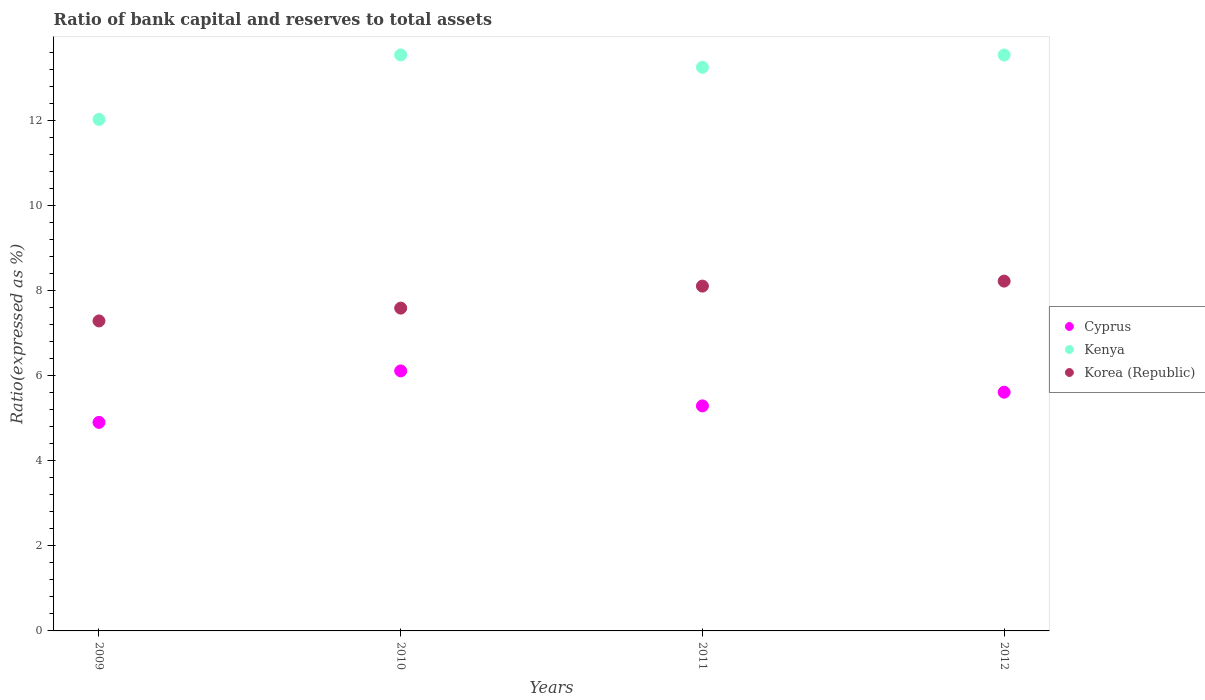How many different coloured dotlines are there?
Keep it short and to the point. 3. Is the number of dotlines equal to the number of legend labels?
Your response must be concise. Yes. What is the ratio of bank capital and reserves to total assets in Cyprus in 2011?
Provide a short and direct response. 5.3. Across all years, what is the maximum ratio of bank capital and reserves to total assets in Kenya?
Provide a short and direct response. 13.55. Across all years, what is the minimum ratio of bank capital and reserves to total assets in Kenya?
Provide a short and direct response. 12.04. In which year was the ratio of bank capital and reserves to total assets in Kenya maximum?
Offer a terse response. 2010. In which year was the ratio of bank capital and reserves to total assets in Kenya minimum?
Provide a short and direct response. 2009. What is the total ratio of bank capital and reserves to total assets in Korea (Republic) in the graph?
Your answer should be compact. 31.23. What is the difference between the ratio of bank capital and reserves to total assets in Korea (Republic) in 2010 and that in 2012?
Your answer should be compact. -0.64. What is the difference between the ratio of bank capital and reserves to total assets in Kenya in 2012 and the ratio of bank capital and reserves to total assets in Korea (Republic) in 2009?
Make the answer very short. 6.26. What is the average ratio of bank capital and reserves to total assets in Korea (Republic) per year?
Your answer should be compact. 7.81. In the year 2012, what is the difference between the ratio of bank capital and reserves to total assets in Korea (Republic) and ratio of bank capital and reserves to total assets in Kenya?
Provide a succinct answer. -5.32. In how many years, is the ratio of bank capital and reserves to total assets in Korea (Republic) greater than 5.2 %?
Keep it short and to the point. 4. What is the ratio of the ratio of bank capital and reserves to total assets in Korea (Republic) in 2009 to that in 2010?
Offer a very short reply. 0.96. Is the difference between the ratio of bank capital and reserves to total assets in Korea (Republic) in 2011 and 2012 greater than the difference between the ratio of bank capital and reserves to total assets in Kenya in 2011 and 2012?
Provide a succinct answer. Yes. What is the difference between the highest and the second highest ratio of bank capital and reserves to total assets in Kenya?
Make the answer very short. 0. What is the difference between the highest and the lowest ratio of bank capital and reserves to total assets in Cyprus?
Provide a short and direct response. 1.21. In how many years, is the ratio of bank capital and reserves to total assets in Kenya greater than the average ratio of bank capital and reserves to total assets in Kenya taken over all years?
Your response must be concise. 3. Is it the case that in every year, the sum of the ratio of bank capital and reserves to total assets in Cyprus and ratio of bank capital and reserves to total assets in Korea (Republic)  is greater than the ratio of bank capital and reserves to total assets in Kenya?
Offer a terse response. Yes. Is the ratio of bank capital and reserves to total assets in Cyprus strictly less than the ratio of bank capital and reserves to total assets in Kenya over the years?
Offer a terse response. Yes. How many dotlines are there?
Provide a succinct answer. 3. How many years are there in the graph?
Provide a short and direct response. 4. Are the values on the major ticks of Y-axis written in scientific E-notation?
Keep it short and to the point. No. Does the graph contain grids?
Give a very brief answer. No. Where does the legend appear in the graph?
Provide a succinct answer. Center right. How are the legend labels stacked?
Offer a very short reply. Vertical. What is the title of the graph?
Provide a short and direct response. Ratio of bank capital and reserves to total assets. Does "Liberia" appear as one of the legend labels in the graph?
Your answer should be very brief. No. What is the label or title of the X-axis?
Provide a succinct answer. Years. What is the label or title of the Y-axis?
Offer a very short reply. Ratio(expressed as %). What is the Ratio(expressed as %) of Cyprus in 2009?
Make the answer very short. 4.91. What is the Ratio(expressed as %) in Kenya in 2009?
Provide a succinct answer. 12.04. What is the Ratio(expressed as %) in Korea (Republic) in 2009?
Make the answer very short. 7.29. What is the Ratio(expressed as %) in Cyprus in 2010?
Keep it short and to the point. 6.12. What is the Ratio(expressed as %) of Kenya in 2010?
Offer a terse response. 13.55. What is the Ratio(expressed as %) in Korea (Republic) in 2010?
Your response must be concise. 7.6. What is the Ratio(expressed as %) of Cyprus in 2011?
Offer a very short reply. 5.3. What is the Ratio(expressed as %) in Kenya in 2011?
Give a very brief answer. 13.26. What is the Ratio(expressed as %) of Korea (Republic) in 2011?
Ensure brevity in your answer.  8.11. What is the Ratio(expressed as %) in Cyprus in 2012?
Offer a very short reply. 5.62. What is the Ratio(expressed as %) of Kenya in 2012?
Provide a short and direct response. 13.55. What is the Ratio(expressed as %) in Korea (Republic) in 2012?
Your answer should be very brief. 8.23. Across all years, what is the maximum Ratio(expressed as %) of Cyprus?
Ensure brevity in your answer.  6.12. Across all years, what is the maximum Ratio(expressed as %) in Kenya?
Provide a short and direct response. 13.55. Across all years, what is the maximum Ratio(expressed as %) in Korea (Republic)?
Make the answer very short. 8.23. Across all years, what is the minimum Ratio(expressed as %) of Cyprus?
Keep it short and to the point. 4.91. Across all years, what is the minimum Ratio(expressed as %) of Kenya?
Make the answer very short. 12.04. Across all years, what is the minimum Ratio(expressed as %) in Korea (Republic)?
Your answer should be very brief. 7.29. What is the total Ratio(expressed as %) in Cyprus in the graph?
Ensure brevity in your answer.  21.94. What is the total Ratio(expressed as %) of Kenya in the graph?
Ensure brevity in your answer.  52.4. What is the total Ratio(expressed as %) in Korea (Republic) in the graph?
Make the answer very short. 31.23. What is the difference between the Ratio(expressed as %) of Cyprus in 2009 and that in 2010?
Offer a very short reply. -1.21. What is the difference between the Ratio(expressed as %) of Kenya in 2009 and that in 2010?
Provide a short and direct response. -1.52. What is the difference between the Ratio(expressed as %) in Korea (Republic) in 2009 and that in 2010?
Provide a short and direct response. -0.3. What is the difference between the Ratio(expressed as %) of Cyprus in 2009 and that in 2011?
Provide a short and direct response. -0.39. What is the difference between the Ratio(expressed as %) of Kenya in 2009 and that in 2011?
Your response must be concise. -1.23. What is the difference between the Ratio(expressed as %) of Korea (Republic) in 2009 and that in 2011?
Your response must be concise. -0.82. What is the difference between the Ratio(expressed as %) of Cyprus in 2009 and that in 2012?
Make the answer very short. -0.71. What is the difference between the Ratio(expressed as %) of Kenya in 2009 and that in 2012?
Your answer should be very brief. -1.52. What is the difference between the Ratio(expressed as %) in Korea (Republic) in 2009 and that in 2012?
Keep it short and to the point. -0.94. What is the difference between the Ratio(expressed as %) in Cyprus in 2010 and that in 2011?
Ensure brevity in your answer.  0.82. What is the difference between the Ratio(expressed as %) in Kenya in 2010 and that in 2011?
Give a very brief answer. 0.29. What is the difference between the Ratio(expressed as %) in Korea (Republic) in 2010 and that in 2011?
Your answer should be very brief. -0.52. What is the difference between the Ratio(expressed as %) in Cyprus in 2010 and that in 2012?
Make the answer very short. 0.5. What is the difference between the Ratio(expressed as %) in Kenya in 2010 and that in 2012?
Your answer should be very brief. 0. What is the difference between the Ratio(expressed as %) in Korea (Republic) in 2010 and that in 2012?
Give a very brief answer. -0.64. What is the difference between the Ratio(expressed as %) in Cyprus in 2011 and that in 2012?
Offer a terse response. -0.32. What is the difference between the Ratio(expressed as %) in Kenya in 2011 and that in 2012?
Give a very brief answer. -0.29. What is the difference between the Ratio(expressed as %) of Korea (Republic) in 2011 and that in 2012?
Offer a terse response. -0.12. What is the difference between the Ratio(expressed as %) in Cyprus in 2009 and the Ratio(expressed as %) in Kenya in 2010?
Offer a very short reply. -8.65. What is the difference between the Ratio(expressed as %) of Cyprus in 2009 and the Ratio(expressed as %) of Korea (Republic) in 2010?
Ensure brevity in your answer.  -2.69. What is the difference between the Ratio(expressed as %) of Kenya in 2009 and the Ratio(expressed as %) of Korea (Republic) in 2010?
Give a very brief answer. 4.44. What is the difference between the Ratio(expressed as %) in Cyprus in 2009 and the Ratio(expressed as %) in Kenya in 2011?
Your answer should be very brief. -8.36. What is the difference between the Ratio(expressed as %) of Cyprus in 2009 and the Ratio(expressed as %) of Korea (Republic) in 2011?
Your answer should be compact. -3.21. What is the difference between the Ratio(expressed as %) of Kenya in 2009 and the Ratio(expressed as %) of Korea (Republic) in 2011?
Your response must be concise. 3.92. What is the difference between the Ratio(expressed as %) in Cyprus in 2009 and the Ratio(expressed as %) in Kenya in 2012?
Offer a very short reply. -8.64. What is the difference between the Ratio(expressed as %) of Cyprus in 2009 and the Ratio(expressed as %) of Korea (Republic) in 2012?
Provide a short and direct response. -3.32. What is the difference between the Ratio(expressed as %) in Kenya in 2009 and the Ratio(expressed as %) in Korea (Republic) in 2012?
Your answer should be very brief. 3.8. What is the difference between the Ratio(expressed as %) in Cyprus in 2010 and the Ratio(expressed as %) in Kenya in 2011?
Your answer should be compact. -7.14. What is the difference between the Ratio(expressed as %) of Cyprus in 2010 and the Ratio(expressed as %) of Korea (Republic) in 2011?
Offer a very short reply. -2. What is the difference between the Ratio(expressed as %) in Kenya in 2010 and the Ratio(expressed as %) in Korea (Republic) in 2011?
Give a very brief answer. 5.44. What is the difference between the Ratio(expressed as %) in Cyprus in 2010 and the Ratio(expressed as %) in Kenya in 2012?
Provide a succinct answer. -7.43. What is the difference between the Ratio(expressed as %) in Cyprus in 2010 and the Ratio(expressed as %) in Korea (Republic) in 2012?
Your answer should be compact. -2.11. What is the difference between the Ratio(expressed as %) in Kenya in 2010 and the Ratio(expressed as %) in Korea (Republic) in 2012?
Provide a succinct answer. 5.32. What is the difference between the Ratio(expressed as %) of Cyprus in 2011 and the Ratio(expressed as %) of Kenya in 2012?
Provide a short and direct response. -8.26. What is the difference between the Ratio(expressed as %) in Cyprus in 2011 and the Ratio(expressed as %) in Korea (Republic) in 2012?
Offer a terse response. -2.94. What is the difference between the Ratio(expressed as %) of Kenya in 2011 and the Ratio(expressed as %) of Korea (Republic) in 2012?
Give a very brief answer. 5.03. What is the average Ratio(expressed as %) of Cyprus per year?
Your response must be concise. 5.48. What is the average Ratio(expressed as %) of Kenya per year?
Your response must be concise. 13.1. What is the average Ratio(expressed as %) of Korea (Republic) per year?
Keep it short and to the point. 7.81. In the year 2009, what is the difference between the Ratio(expressed as %) in Cyprus and Ratio(expressed as %) in Kenya?
Offer a terse response. -7.13. In the year 2009, what is the difference between the Ratio(expressed as %) in Cyprus and Ratio(expressed as %) in Korea (Republic)?
Give a very brief answer. -2.39. In the year 2009, what is the difference between the Ratio(expressed as %) of Kenya and Ratio(expressed as %) of Korea (Republic)?
Ensure brevity in your answer.  4.74. In the year 2010, what is the difference between the Ratio(expressed as %) in Cyprus and Ratio(expressed as %) in Kenya?
Your answer should be very brief. -7.43. In the year 2010, what is the difference between the Ratio(expressed as %) of Cyprus and Ratio(expressed as %) of Korea (Republic)?
Provide a short and direct response. -1.48. In the year 2010, what is the difference between the Ratio(expressed as %) in Kenya and Ratio(expressed as %) in Korea (Republic)?
Provide a short and direct response. 5.96. In the year 2011, what is the difference between the Ratio(expressed as %) of Cyprus and Ratio(expressed as %) of Kenya?
Ensure brevity in your answer.  -7.97. In the year 2011, what is the difference between the Ratio(expressed as %) of Cyprus and Ratio(expressed as %) of Korea (Republic)?
Make the answer very short. -2.82. In the year 2011, what is the difference between the Ratio(expressed as %) of Kenya and Ratio(expressed as %) of Korea (Republic)?
Ensure brevity in your answer.  5.15. In the year 2012, what is the difference between the Ratio(expressed as %) in Cyprus and Ratio(expressed as %) in Kenya?
Your answer should be very brief. -7.93. In the year 2012, what is the difference between the Ratio(expressed as %) of Cyprus and Ratio(expressed as %) of Korea (Republic)?
Provide a succinct answer. -2.61. In the year 2012, what is the difference between the Ratio(expressed as %) in Kenya and Ratio(expressed as %) in Korea (Republic)?
Offer a terse response. 5.32. What is the ratio of the Ratio(expressed as %) of Cyprus in 2009 to that in 2010?
Give a very brief answer. 0.8. What is the ratio of the Ratio(expressed as %) in Kenya in 2009 to that in 2010?
Your response must be concise. 0.89. What is the ratio of the Ratio(expressed as %) of Korea (Republic) in 2009 to that in 2010?
Ensure brevity in your answer.  0.96. What is the ratio of the Ratio(expressed as %) in Cyprus in 2009 to that in 2011?
Provide a short and direct response. 0.93. What is the ratio of the Ratio(expressed as %) in Kenya in 2009 to that in 2011?
Keep it short and to the point. 0.91. What is the ratio of the Ratio(expressed as %) of Korea (Republic) in 2009 to that in 2011?
Make the answer very short. 0.9. What is the ratio of the Ratio(expressed as %) of Cyprus in 2009 to that in 2012?
Provide a short and direct response. 0.87. What is the ratio of the Ratio(expressed as %) in Kenya in 2009 to that in 2012?
Offer a terse response. 0.89. What is the ratio of the Ratio(expressed as %) of Korea (Republic) in 2009 to that in 2012?
Your response must be concise. 0.89. What is the ratio of the Ratio(expressed as %) in Cyprus in 2010 to that in 2011?
Make the answer very short. 1.16. What is the ratio of the Ratio(expressed as %) of Kenya in 2010 to that in 2011?
Keep it short and to the point. 1.02. What is the ratio of the Ratio(expressed as %) of Korea (Republic) in 2010 to that in 2011?
Ensure brevity in your answer.  0.94. What is the ratio of the Ratio(expressed as %) of Cyprus in 2010 to that in 2012?
Provide a short and direct response. 1.09. What is the ratio of the Ratio(expressed as %) in Kenya in 2010 to that in 2012?
Your answer should be very brief. 1. What is the ratio of the Ratio(expressed as %) in Korea (Republic) in 2010 to that in 2012?
Your answer should be compact. 0.92. What is the ratio of the Ratio(expressed as %) in Cyprus in 2011 to that in 2012?
Your answer should be compact. 0.94. What is the ratio of the Ratio(expressed as %) in Kenya in 2011 to that in 2012?
Make the answer very short. 0.98. What is the ratio of the Ratio(expressed as %) of Korea (Republic) in 2011 to that in 2012?
Your answer should be very brief. 0.99. What is the difference between the highest and the second highest Ratio(expressed as %) in Cyprus?
Make the answer very short. 0.5. What is the difference between the highest and the second highest Ratio(expressed as %) in Kenya?
Keep it short and to the point. 0. What is the difference between the highest and the second highest Ratio(expressed as %) in Korea (Republic)?
Give a very brief answer. 0.12. What is the difference between the highest and the lowest Ratio(expressed as %) in Cyprus?
Keep it short and to the point. 1.21. What is the difference between the highest and the lowest Ratio(expressed as %) in Kenya?
Your answer should be very brief. 1.52. What is the difference between the highest and the lowest Ratio(expressed as %) of Korea (Republic)?
Ensure brevity in your answer.  0.94. 